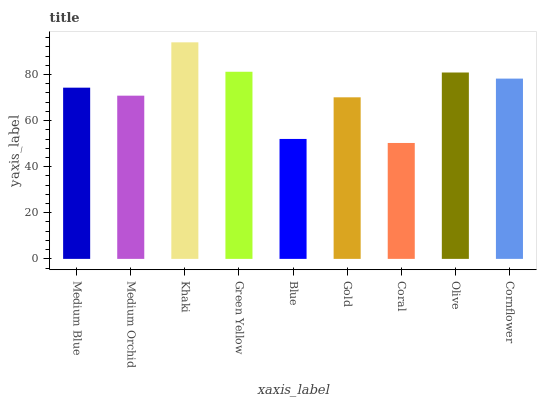Is Coral the minimum?
Answer yes or no. Yes. Is Khaki the maximum?
Answer yes or no. Yes. Is Medium Orchid the minimum?
Answer yes or no. No. Is Medium Orchid the maximum?
Answer yes or no. No. Is Medium Blue greater than Medium Orchid?
Answer yes or no. Yes. Is Medium Orchid less than Medium Blue?
Answer yes or no. Yes. Is Medium Orchid greater than Medium Blue?
Answer yes or no. No. Is Medium Blue less than Medium Orchid?
Answer yes or no. No. Is Medium Blue the high median?
Answer yes or no. Yes. Is Medium Blue the low median?
Answer yes or no. Yes. Is Coral the high median?
Answer yes or no. No. Is Green Yellow the low median?
Answer yes or no. No. 